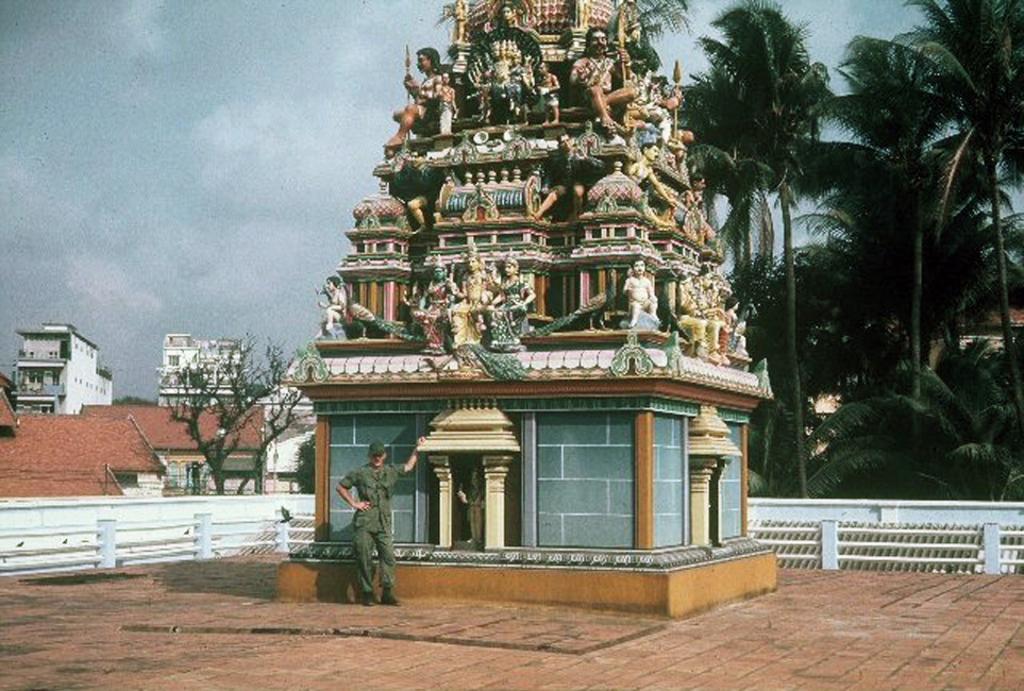In one or two sentences, can you explain what this image depicts? In this image there is a person standing in front of the temple and there are sculptures on the temple. Behind the temple there is a fence. In the background of the image there are trees, buildings. At the top of the image there are clouds in the sky. 